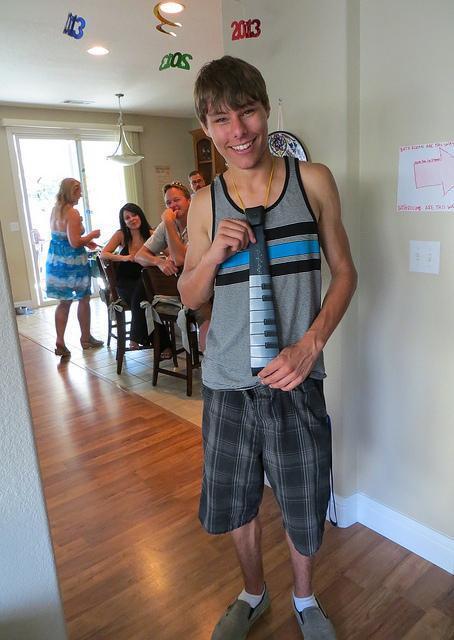How many people are in the photo?
Give a very brief answer. 3. How many chairs are there?
Give a very brief answer. 2. How many birds are there?
Give a very brief answer. 0. 